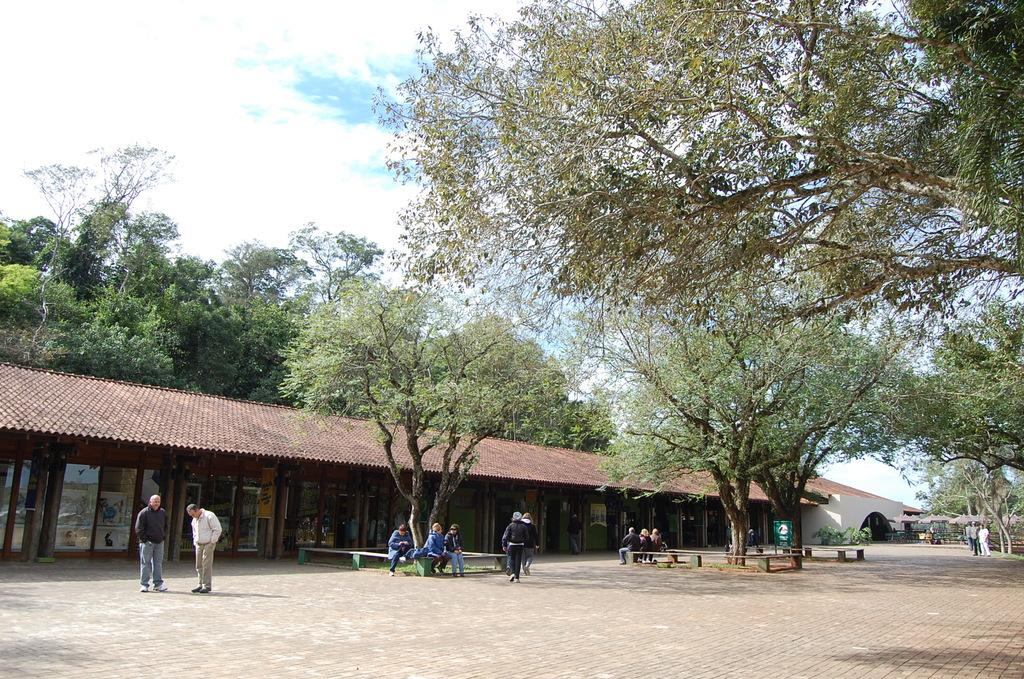Who can be seen in the image? There are people in the image. What are the people doing in the image? Some people are sitting on benches. What type of structures are visible in the image? There are houses in the image. What other natural elements can be seen in the image? There are trees in the image. What is visible in the background of the image? The sky is visible in the image. What type of crack is visible on the base of the rod in the image? There is no rod or crack present in the image. 